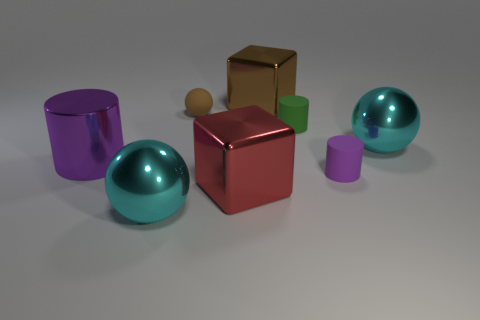Add 1 green matte cylinders. How many objects exist? 9 Subtract all balls. How many objects are left? 5 Add 4 tiny brown matte balls. How many tiny brown matte balls are left? 5 Add 4 cyan spheres. How many cyan spheres exist? 6 Subtract 0 red balls. How many objects are left? 8 Subtract all tiny purple rubber cylinders. Subtract all shiny spheres. How many objects are left? 5 